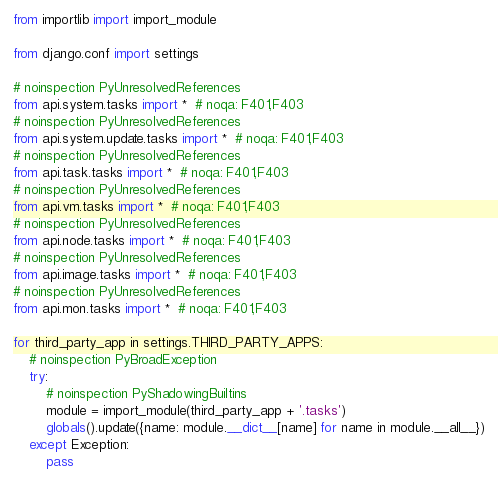<code> <loc_0><loc_0><loc_500><loc_500><_Python_>from importlib import import_module

from django.conf import settings

# noinspection PyUnresolvedReferences
from api.system.tasks import *  # noqa: F401,F403
# noinspection PyUnresolvedReferences
from api.system.update.tasks import *  # noqa: F401,F403
# noinspection PyUnresolvedReferences
from api.task.tasks import *  # noqa: F401,F403
# noinspection PyUnresolvedReferences
from api.vm.tasks import *  # noqa: F401,F403
# noinspection PyUnresolvedReferences
from api.node.tasks import *  # noqa: F401,F403
# noinspection PyUnresolvedReferences
from api.image.tasks import *  # noqa: F401,F403
# noinspection PyUnresolvedReferences
from api.mon.tasks import *  # noqa: F401,F403

for third_party_app in settings.THIRD_PARTY_APPS:
    # noinspection PyBroadException
    try:
        # noinspection PyShadowingBuiltins
        module = import_module(third_party_app + '.tasks')
        globals().update({name: module.__dict__[name] for name in module.__all__})
    except Exception:
        pass
</code> 